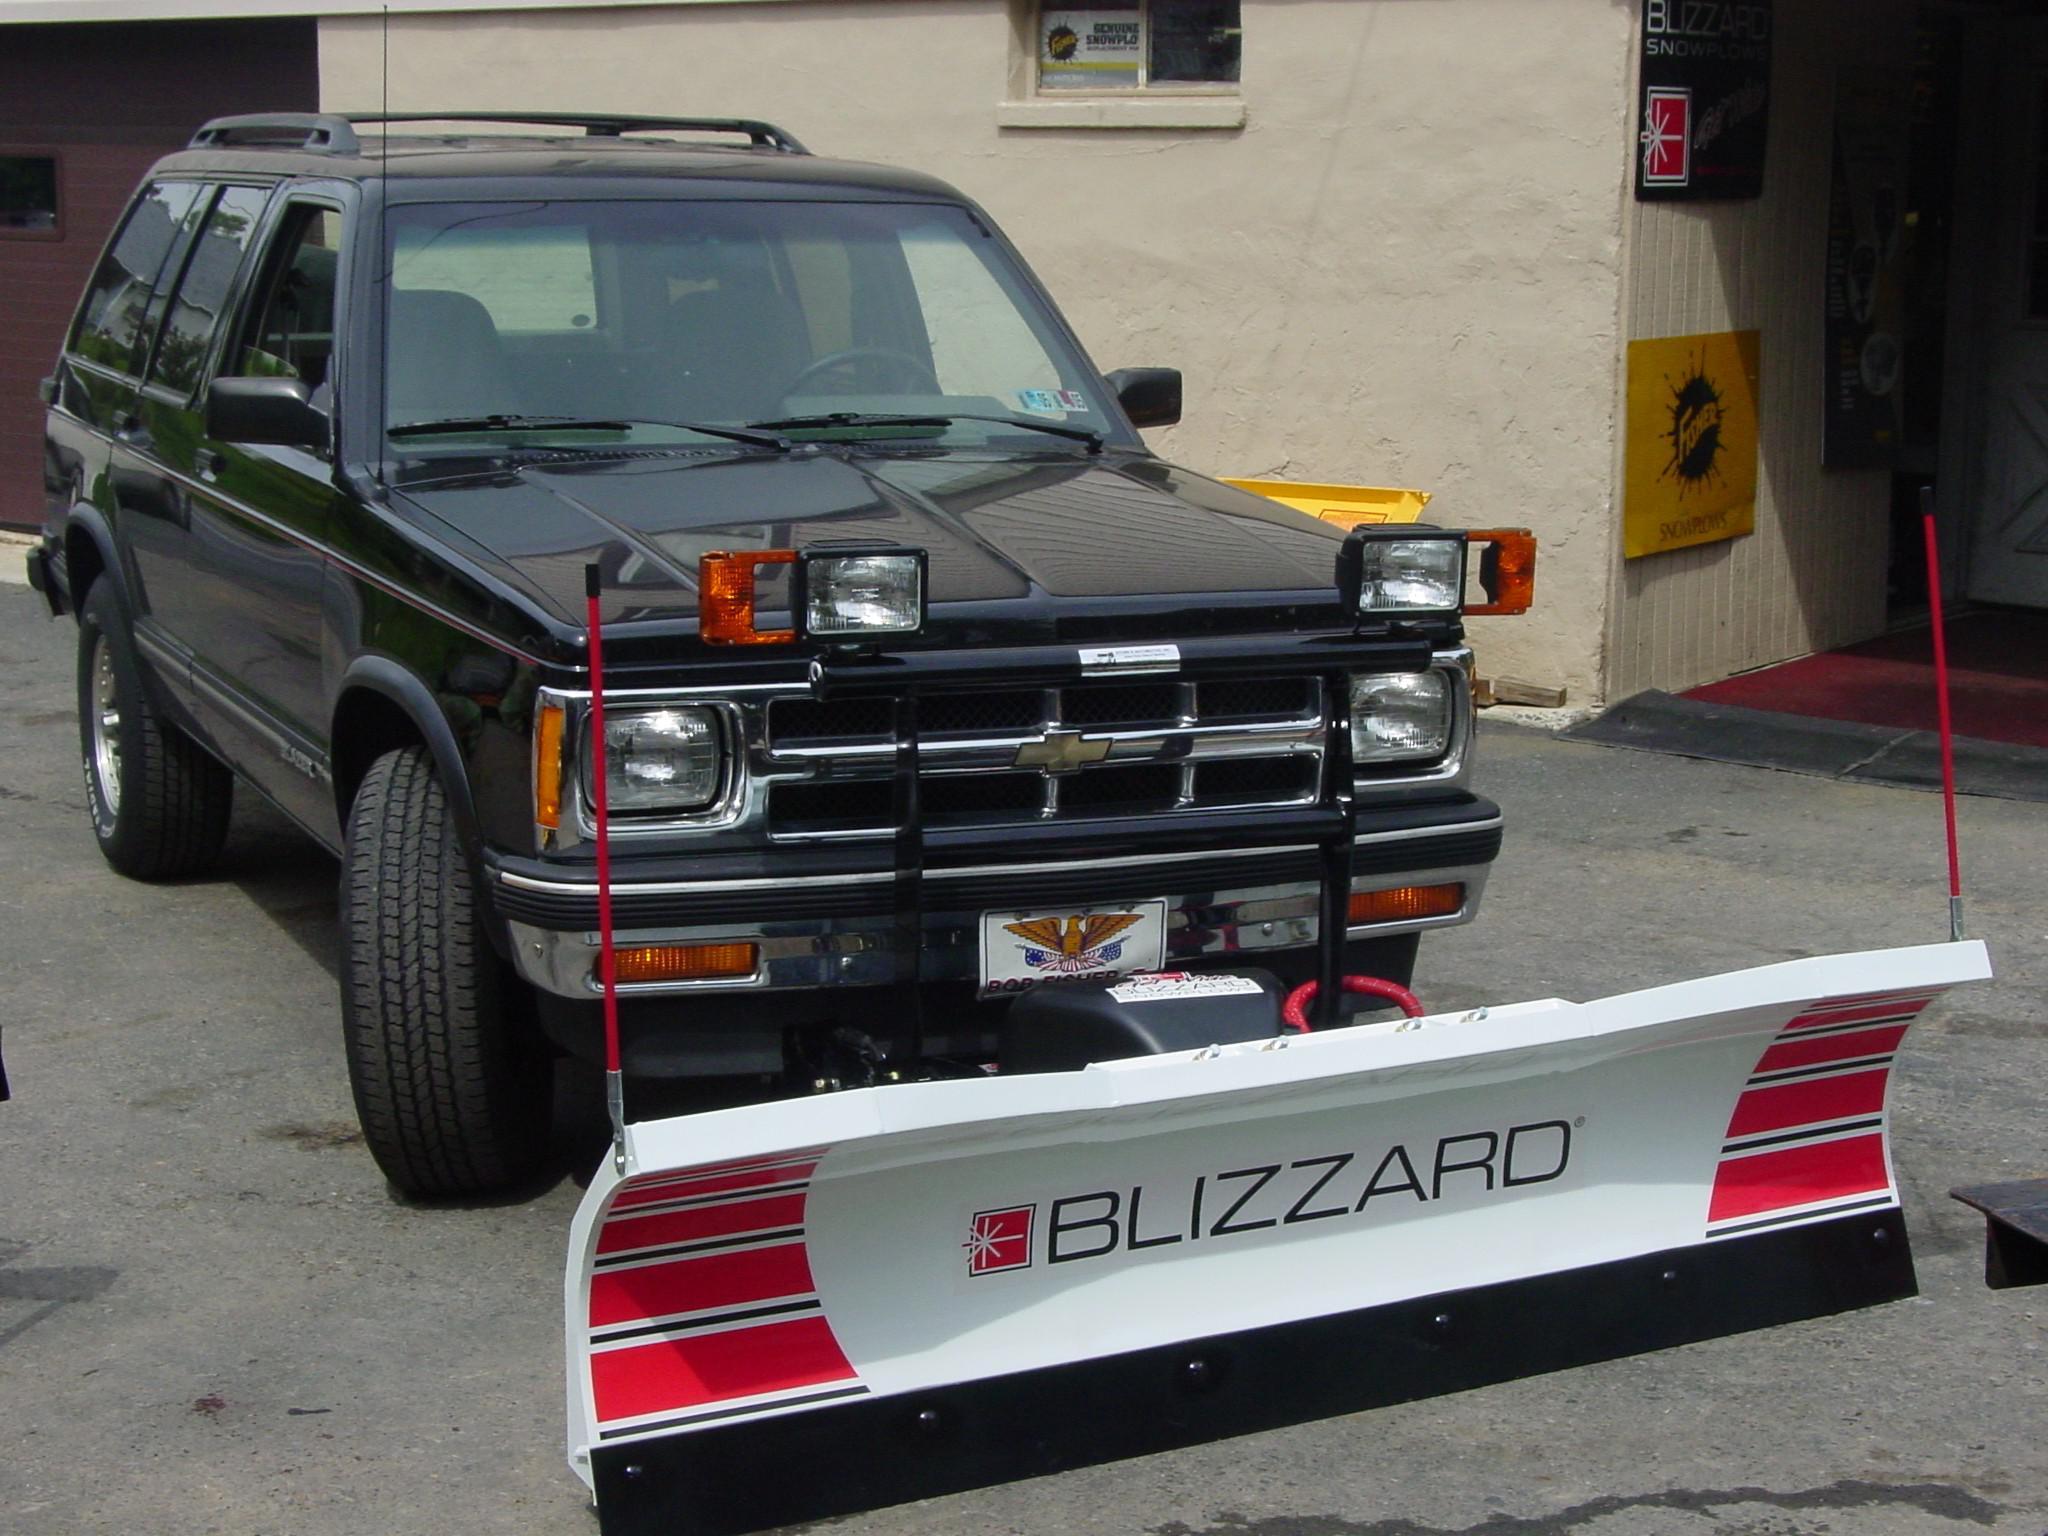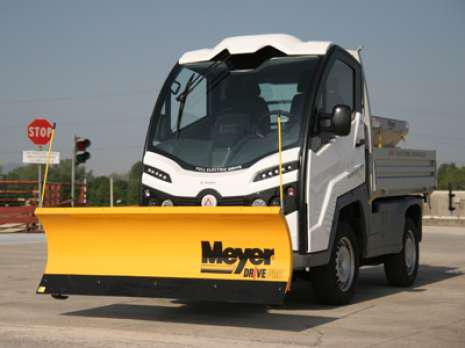The first image is the image on the left, the second image is the image on the right. Considering the images on both sides, is "At least one snowplow is not yellow." valid? Answer yes or no. Yes. 